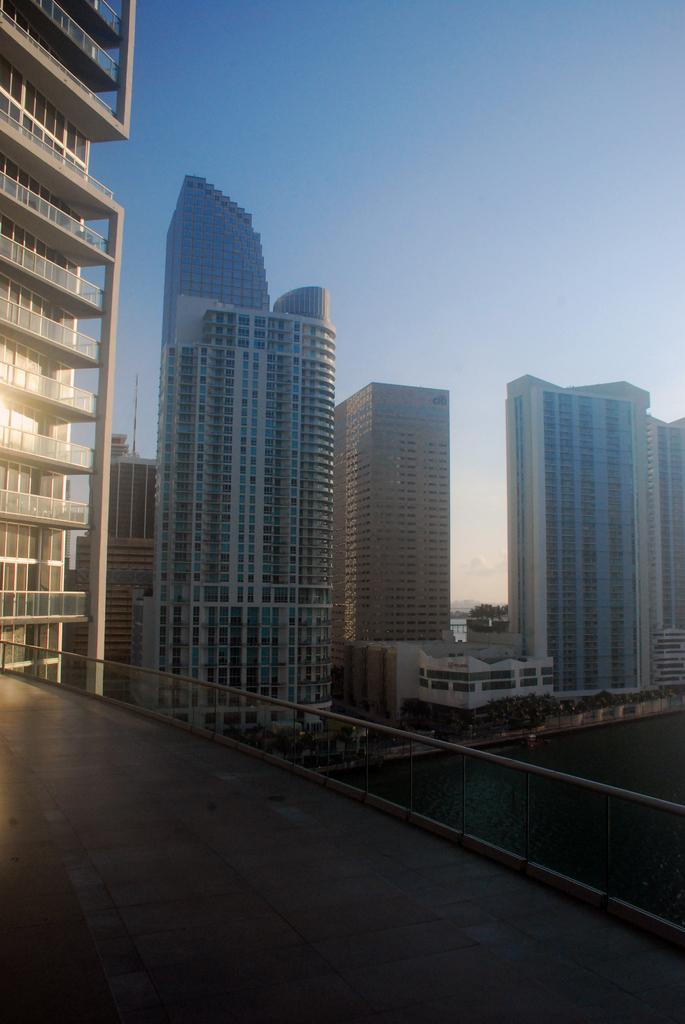What type of surface is visible in the image? There is a surface with railings in the image. What can be seen on the right side of the image? There is water on the right side of the image. What is visible in the background of the image? There are many buildings and the sky in the background of the image. Where is the cactus located in the image? There is no cactus present in the image. What type of lake can be seen in the image? There is no lake present in the image. 